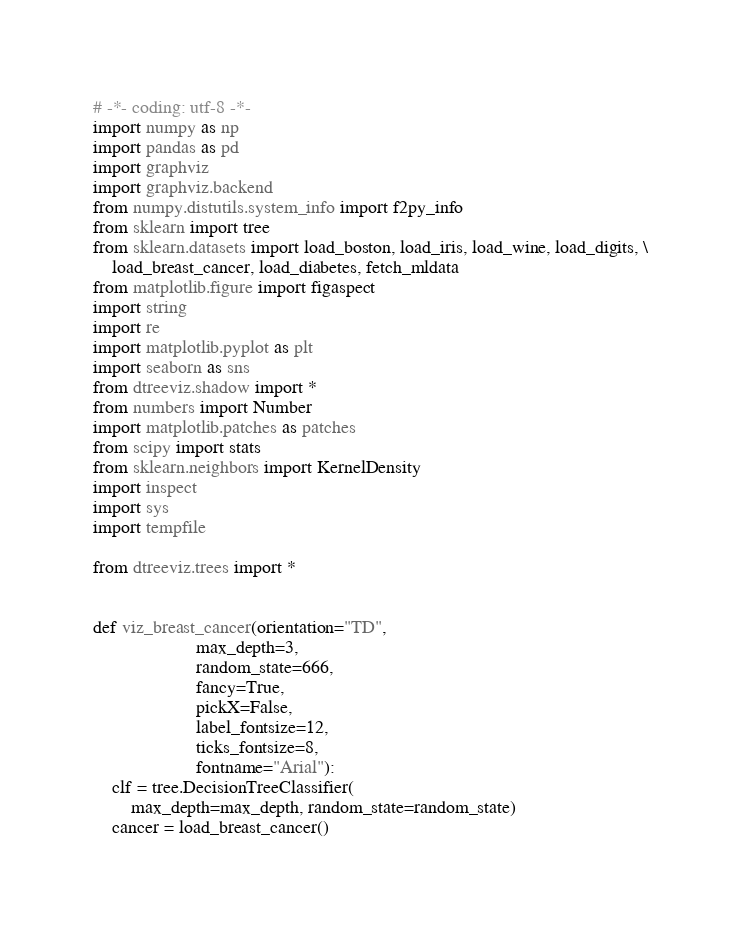Convert code to text. <code><loc_0><loc_0><loc_500><loc_500><_Python_># -*- coding: utf-8 -*-
import numpy as np
import pandas as pd
import graphviz
import graphviz.backend
from numpy.distutils.system_info import f2py_info
from sklearn import tree
from sklearn.datasets import load_boston, load_iris, load_wine, load_digits, \
    load_breast_cancer, load_diabetes, fetch_mldata
from matplotlib.figure import figaspect
import string
import re
import matplotlib.pyplot as plt
import seaborn as sns
from dtreeviz.shadow import *
from numbers import Number
import matplotlib.patches as patches
from scipy import stats
from sklearn.neighbors import KernelDensity
import inspect
import sys
import tempfile

from dtreeviz.trees import *


def viz_breast_cancer(orientation="TD",
                      max_depth=3,
                      random_state=666,
                      fancy=True,
                      pickX=False,
                      label_fontsize=12,
                      ticks_fontsize=8,
                      fontname="Arial"):
    clf = tree.DecisionTreeClassifier(
        max_depth=max_depth, random_state=random_state)
    cancer = load_breast_cancer()
</code> 